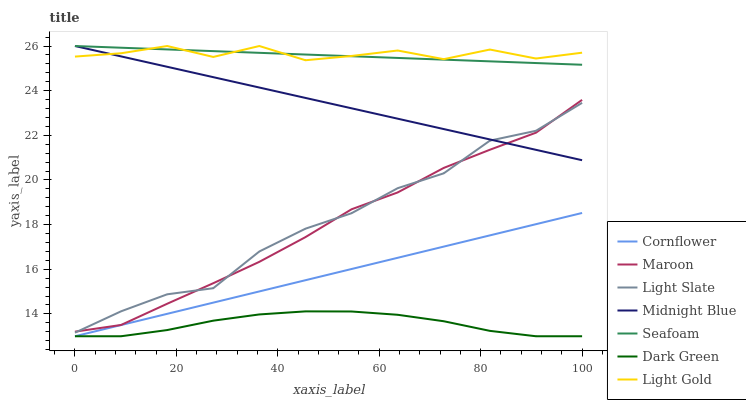Does Dark Green have the minimum area under the curve?
Answer yes or no. Yes. Does Light Gold have the maximum area under the curve?
Answer yes or no. Yes. Does Midnight Blue have the minimum area under the curve?
Answer yes or no. No. Does Midnight Blue have the maximum area under the curve?
Answer yes or no. No. Is Midnight Blue the smoothest?
Answer yes or no. Yes. Is Light Gold the roughest?
Answer yes or no. Yes. Is Light Slate the smoothest?
Answer yes or no. No. Is Light Slate the roughest?
Answer yes or no. No. Does Cornflower have the lowest value?
Answer yes or no. Yes. Does Midnight Blue have the lowest value?
Answer yes or no. No. Does Light Gold have the highest value?
Answer yes or no. Yes. Does Light Slate have the highest value?
Answer yes or no. No. Is Cornflower less than Midnight Blue?
Answer yes or no. Yes. Is Midnight Blue greater than Cornflower?
Answer yes or no. Yes. Does Seafoam intersect Light Gold?
Answer yes or no. Yes. Is Seafoam less than Light Gold?
Answer yes or no. No. Is Seafoam greater than Light Gold?
Answer yes or no. No. Does Cornflower intersect Midnight Blue?
Answer yes or no. No. 